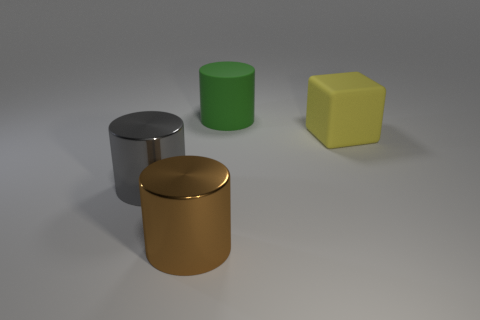Are there the same number of big shiny things that are behind the cube and yellow objects that are in front of the large gray metallic thing?
Ensure brevity in your answer.  Yes. There is a yellow block; are there any rubber cylinders in front of it?
Your answer should be very brief. No. What color is the large object on the right side of the green thing?
Offer a very short reply. Yellow. The large object right of the cylinder that is behind the yellow rubber object is made of what material?
Offer a very short reply. Rubber. Are there fewer brown cylinders to the right of the large green matte object than cubes to the left of the big gray object?
Make the answer very short. No. What number of gray objects are either large matte cylinders or large things?
Provide a short and direct response. 1. Is the number of big yellow matte blocks behind the yellow object the same as the number of matte cylinders?
Offer a terse response. No. How many things are large yellow objects or big things that are left of the large green thing?
Make the answer very short. 3. Is the cube the same color as the matte cylinder?
Make the answer very short. No. Is there another large gray cylinder made of the same material as the gray cylinder?
Your answer should be very brief. No. 